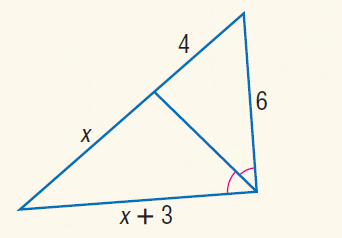Question: Find x.
Choices:
A. 6
B. 7
C. 8
D. 9
Answer with the letter. Answer: A 